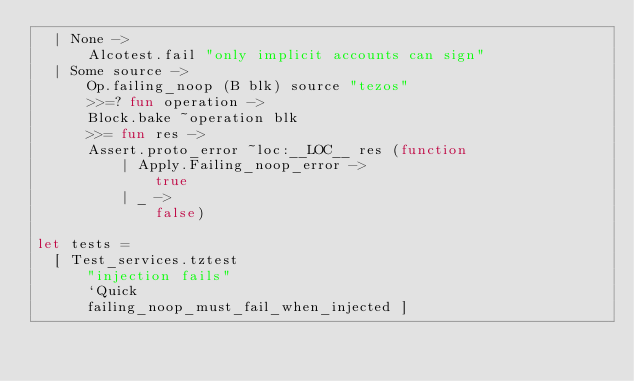<code> <loc_0><loc_0><loc_500><loc_500><_OCaml_>  | None ->
      Alcotest.fail "only implicit accounts can sign"
  | Some source ->
      Op.failing_noop (B blk) source "tezos"
      >>=? fun operation ->
      Block.bake ~operation blk
      >>= fun res ->
      Assert.proto_error ~loc:__LOC__ res (function
          | Apply.Failing_noop_error ->
              true
          | _ ->
              false)

let tests =
  [ Test_services.tztest
      "injection fails"
      `Quick
      failing_noop_must_fail_when_injected ]
</code> 